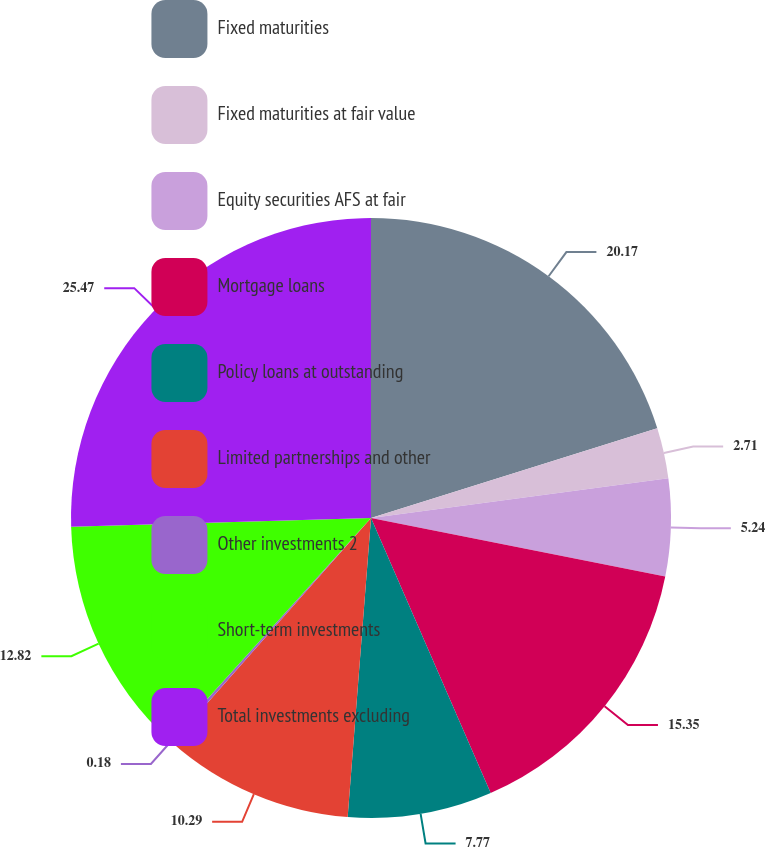Convert chart to OTSL. <chart><loc_0><loc_0><loc_500><loc_500><pie_chart><fcel>Fixed maturities<fcel>Fixed maturities at fair value<fcel>Equity securities AFS at fair<fcel>Mortgage loans<fcel>Policy loans at outstanding<fcel>Limited partnerships and other<fcel>Other investments 2<fcel>Short-term investments<fcel>Total investments excluding<nl><fcel>20.17%<fcel>2.71%<fcel>5.24%<fcel>15.35%<fcel>7.77%<fcel>10.29%<fcel>0.18%<fcel>12.82%<fcel>25.47%<nl></chart> 